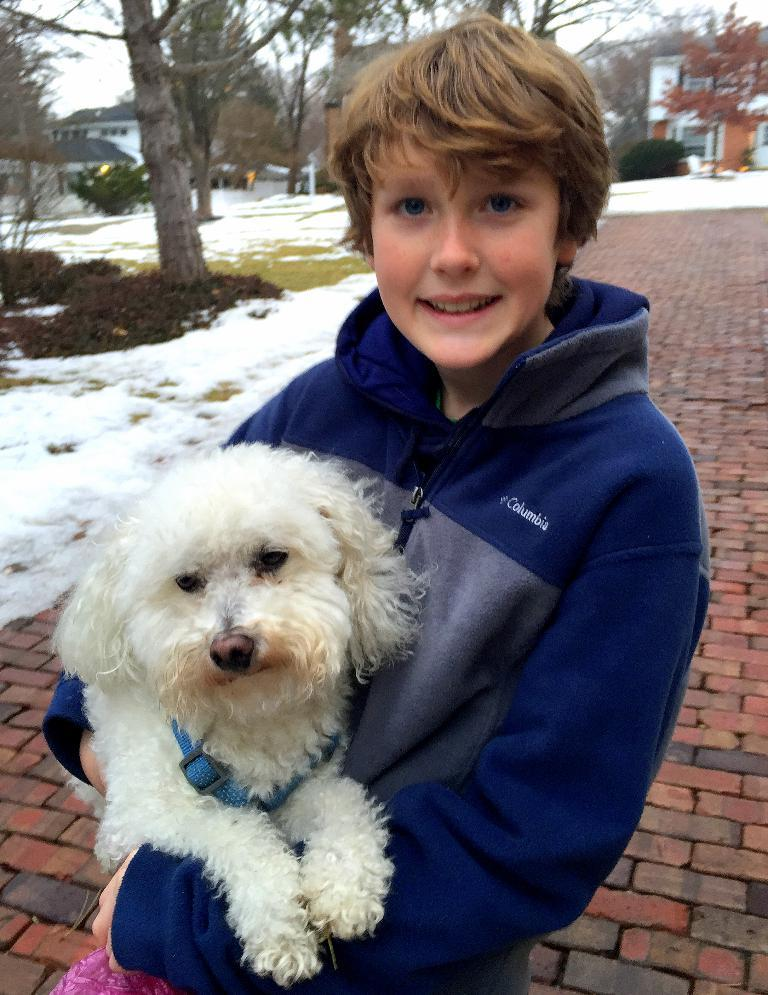Who is in the image? There is a boy in the image. What is the boy holding? The boy is holding a dog. What is the weather like in the image? There is snow visible in the image, indicating a cold or wintery setting. What type of structures can be seen in the image? There are buildings in the image. What type of vegetation is present in the image? There are trees and plants in the image. What is on the ground in the image? There are objects on the ground in the image. What can be seen in the background of the image? The sky is visible in the background of the image. What type of rod is being used to stir the coal in the image? There is no rod or coal present in the image; it features a boy holding a dog in a snowy environment with buildings, trees, plants, and objects on the ground. What type of party is being held in the image? There is no party depicted in the image; it shows a boy holding a dog in a snowy environment with buildings, trees, plants, and objects on the ground. 